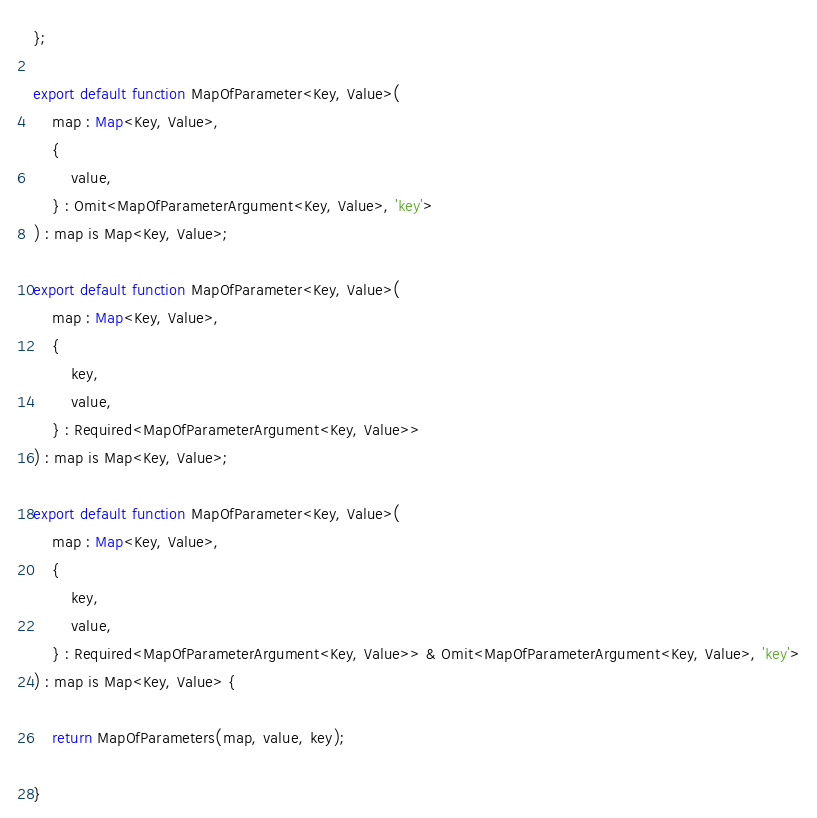Convert code to text. <code><loc_0><loc_0><loc_500><loc_500><_TypeScript_>};

export default function MapOfParameter<Key, Value>(
    map : Map<Key, Value>,
    {
        value,
    } : Omit<MapOfParameterArgument<Key, Value>, 'key'>
) : map is Map<Key, Value>;

export default function MapOfParameter<Key, Value>(
    map : Map<Key, Value>,
    {
        key,
        value,
    } : Required<MapOfParameterArgument<Key, Value>>
) : map is Map<Key, Value>;

export default function MapOfParameter<Key, Value>(
    map : Map<Key, Value>,
    {
        key,
        value,
    } : Required<MapOfParameterArgument<Key, Value>> & Omit<MapOfParameterArgument<Key, Value>, 'key'>
) : map is Map<Key, Value> {

    return MapOfParameters(map, value, key);

}
</code> 